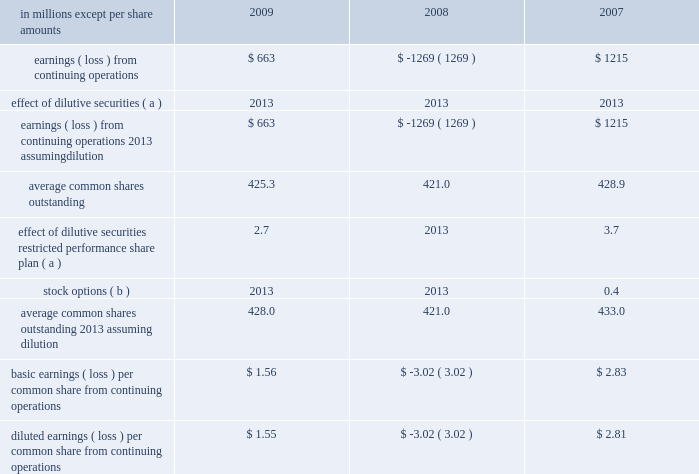In april 2009 , the fasb issued additional guidance under asc 820 which provides guidance on estimat- ing the fair value of an asset or liability ( financial or nonfinancial ) when the volume and level of activity for the asset or liability have significantly decreased , and on identifying transactions that are not orderly .
The application of the requirements of this guidance did not have a material effect on the accompanying consolidated financial statements .
In august 2009 , the fasb issued asu 2009-05 , 201cmeasuring liabilities at fair value , 201d which further amends asc 820 by providing clarification for cir- cumstances in which a quoted price in an active market for the identical liability is not available .
The company included the disclosures required by this guidance in the accompanying consolidated financial statements .
Accounting for uncertainty in income taxes in june 2006 , the fasb issued guidance under asc 740 , 201cincome taxes 201d ( formerly fin 48 ) .
This guid- ance prescribes a recognition threshold and measurement attribute for the financial statement recognition and measurement of a tax position taken or expected to be taken in tax returns .
Specifically , the financial statement effects of a tax position may be recognized only when it is determined that it is 201cmore likely than not 201d that , based on its technical merits , the tax position will be sustained upon examination by the relevant tax authority .
The amount recognized shall be measured as the largest amount of tax benefits that exceed a 50% ( 50 % ) probability of being recognized .
This guidance also expands income tax disclosure requirements .
International paper applied the provisions of this guidance begin- ning in the first quarter of 2007 .
The adoption of this guidance resulted in a charge to the beginning bal- ance of retained earnings of $ 94 million at the date of adoption .
Note 3 industry segment information financial information by industry segment and geo- graphic area for 2009 , 2008 and 2007 is presented on pages 47 and 48 .
Effective january 1 , 2008 , the company changed its method of allocating corpo- rate overhead expenses to its business segments to increase the expense amounts allocated to these businesses in reports reviewed by its chief executive officer to facilitate performance comparisons with other companies .
Accordingly , the company has revised its presentation of industry segment operat- ing profit to reflect this change in allocation method , and has adjusted all comparative prior period information on this basis .
Note 4 earnings per share attributable to international paper company common shareholders basic earnings per common share from continuing operations are computed by dividing earnings from continuing operations by the weighted average number of common shares outstanding .
Diluted earnings per common share from continuing oper- ations are computed assuming that all potentially dilutive securities , including 201cin-the-money 201d stock options , were converted into common shares at the beginning of each year .
In addition , the computation of diluted earnings per share reflects the inclusion of contingently convertible securities in periods when dilutive .
A reconciliation of the amounts included in the computation of basic earnings per common share from continuing operations , and diluted earnings per common share from continuing operations is as fol- in millions except per share amounts 2009 2008 2007 .
Average common shares outstanding 2013 assuming dilution 428.0 421.0 433.0 basic earnings ( loss ) per common share from continuing operations $ 1.56 $ ( 3.02 ) $ 2.83 diluted earnings ( loss ) per common share from continuing operations $ 1.55 $ ( 3.02 ) $ 2.81 ( a ) securities are not included in the table in periods when anti- dilutive .
( b ) options to purchase 22.2 million , 25.1 million and 17.5 million shares for the years ended december 31 , 2009 , 2008 and 2007 , respectively , were not included in the computation of diluted common shares outstanding because their exercise price exceeded the average market price of the company 2019s common stock for each respective reporting date .
Note 5 restructuring and other charges this footnote discusses restructuring and other charges recorded for each of the three years included in the period ended december 31 , 2009 .
It .
What was the sum of the earnings ( loss ) from continuing operations? 
Computations: (1215 + (663 + -1269))
Answer: 609.0. 